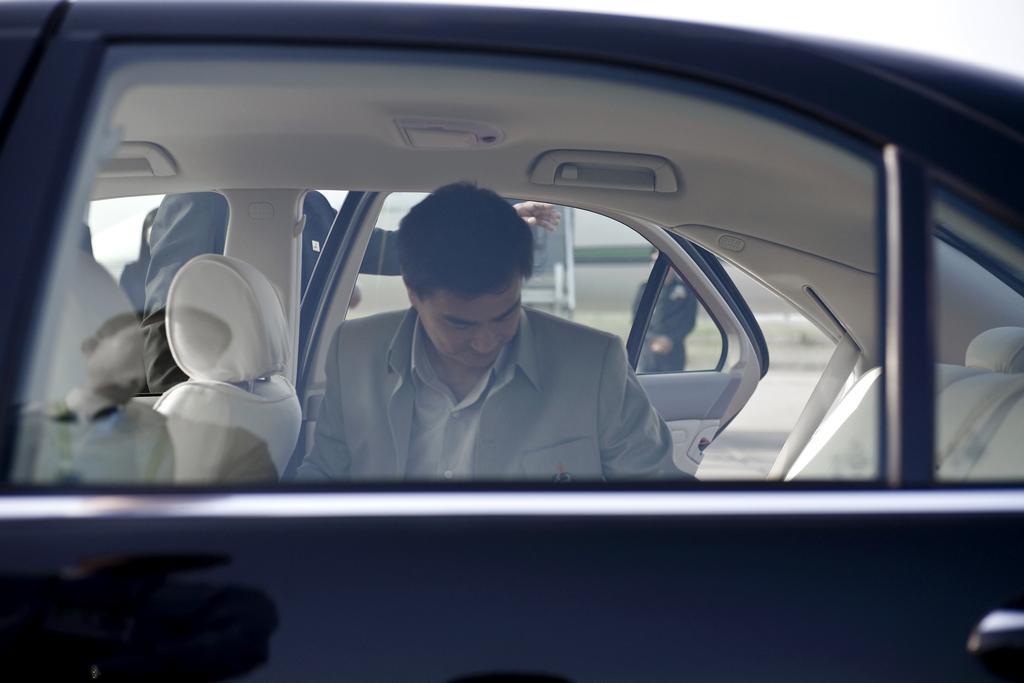Can you describe this image briefly? Person is sitting inside a car. Another person is standing and holding this door. 